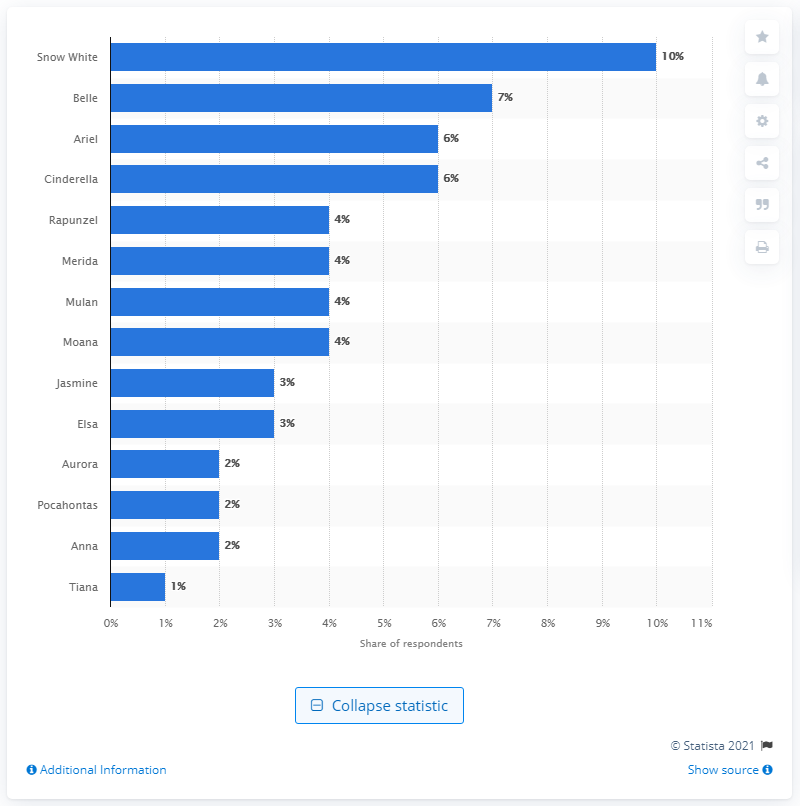Draw attention to some important aspects in this diagram. In the opinion of many, Snow White was the most beloved Disney princess in Britain. 